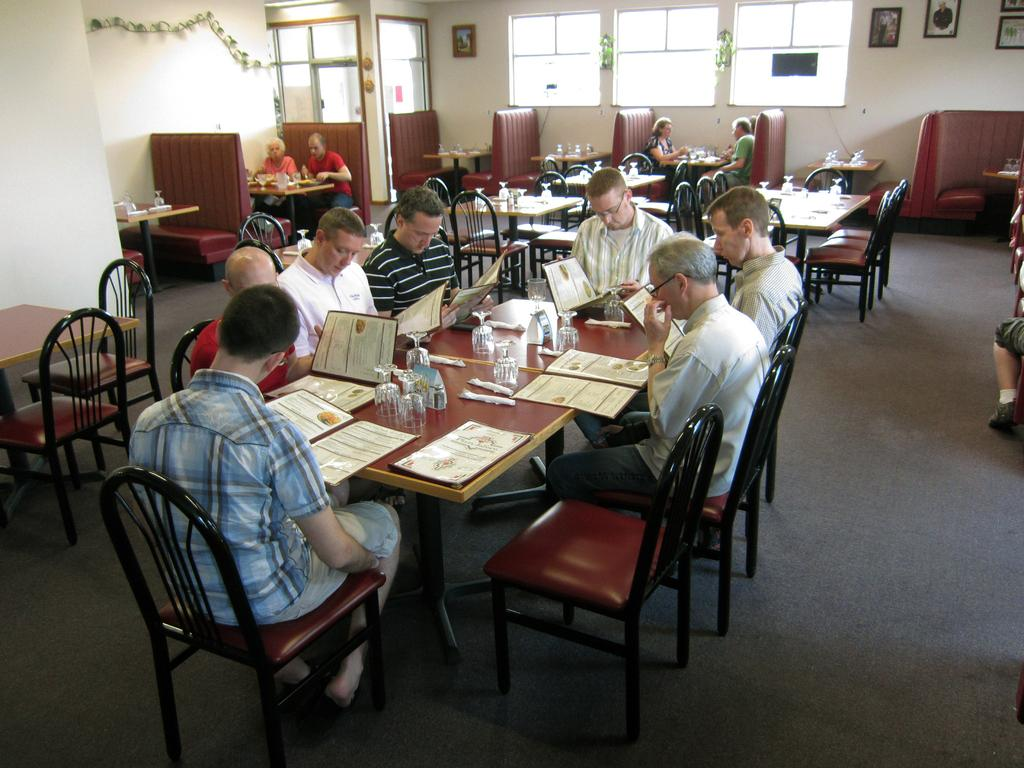What is the person in the image doing? The person is sitting around the table. What is the person sitting on? The person is in a chair. What objects can be seen on the table? There is a glass and a book on the table. What is located on the backside of the table? There is a photo frame on the backside of the table. What can be seen in the room besides the table and chair? There is a window and a wall in the room. What type of silverware is visible in the image? There is no silverware present in the image. Can you see a sink in the image? There is no sink present in the image. 